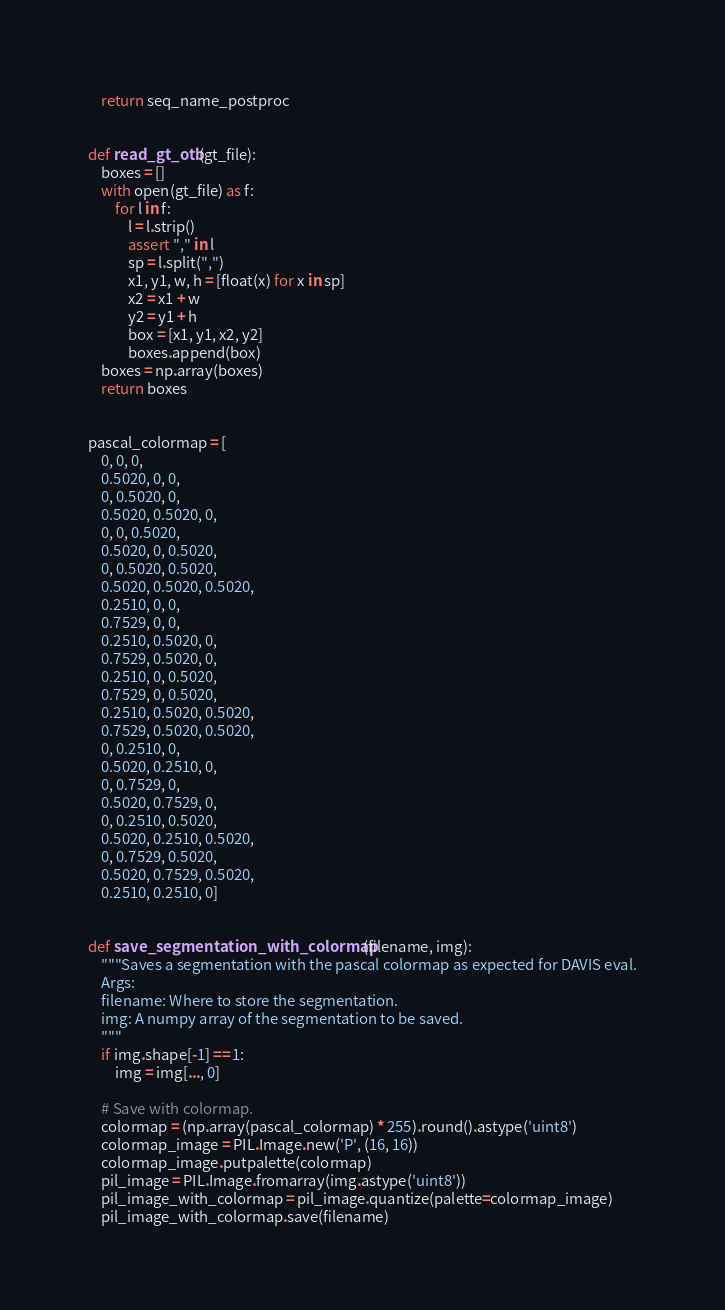<code> <loc_0><loc_0><loc_500><loc_500><_Python_>    return seq_name_postproc


def read_gt_otb(gt_file):
    boxes = []
    with open(gt_file) as f:
        for l in f:
            l = l.strip()
            assert "," in l
            sp = l.split(",")
            x1, y1, w, h = [float(x) for x in sp]
            x2 = x1 + w
            y2 = y1 + h
            box = [x1, y1, x2, y2]
            boxes.append(box)
    boxes = np.array(boxes)
    return boxes


pascal_colormap = [
    0, 0, 0,
    0.5020, 0, 0,
    0, 0.5020, 0,
    0.5020, 0.5020, 0,
    0, 0, 0.5020,
    0.5020, 0, 0.5020,
    0, 0.5020, 0.5020,
    0.5020, 0.5020, 0.5020,
    0.2510, 0, 0,
    0.7529, 0, 0,
    0.2510, 0.5020, 0,
    0.7529, 0.5020, 0,
    0.2510, 0, 0.5020,
    0.7529, 0, 0.5020,
    0.2510, 0.5020, 0.5020,
    0.7529, 0.5020, 0.5020,
    0, 0.2510, 0,
    0.5020, 0.2510, 0,
    0, 0.7529, 0,
    0.5020, 0.7529, 0,
    0, 0.2510, 0.5020,
    0.5020, 0.2510, 0.5020,
    0, 0.7529, 0.5020,
    0.5020, 0.7529, 0.5020,
    0.2510, 0.2510, 0]


def save_segmentation_with_colormap(filename, img):
    """Saves a segmentation with the pascal colormap as expected for DAVIS eval.
    Args:
    filename: Where to store the segmentation.
    img: A numpy array of the segmentation to be saved.
    """
    if img.shape[-1] == 1:
        img = img[..., 0]

    # Save with colormap.
    colormap = (np.array(pascal_colormap) * 255).round().astype('uint8')
    colormap_image = PIL.Image.new('P', (16, 16))
    colormap_image.putpalette(colormap)
    pil_image = PIL.Image.fromarray(img.astype('uint8'))
    pil_image_with_colormap = pil_image.quantize(palette=colormap_image)
    pil_image_with_colormap.save(filename)

</code> 